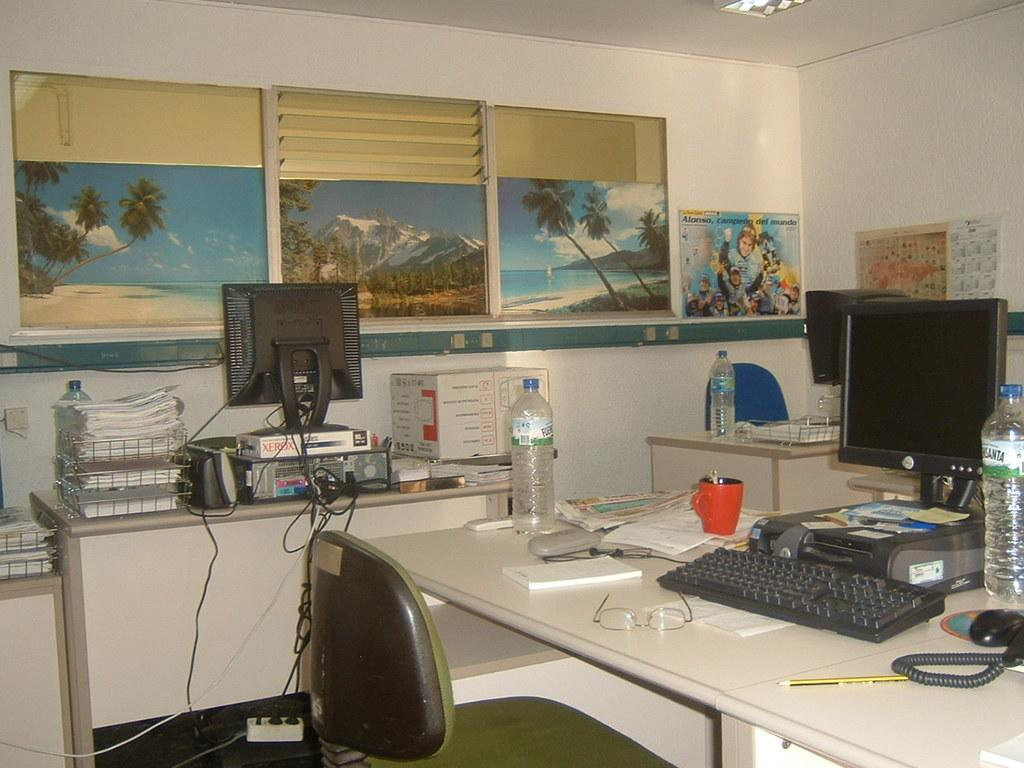<image>
Describe the image concisely. A messy office shows a desk scattered with objects and a Dell computer. 